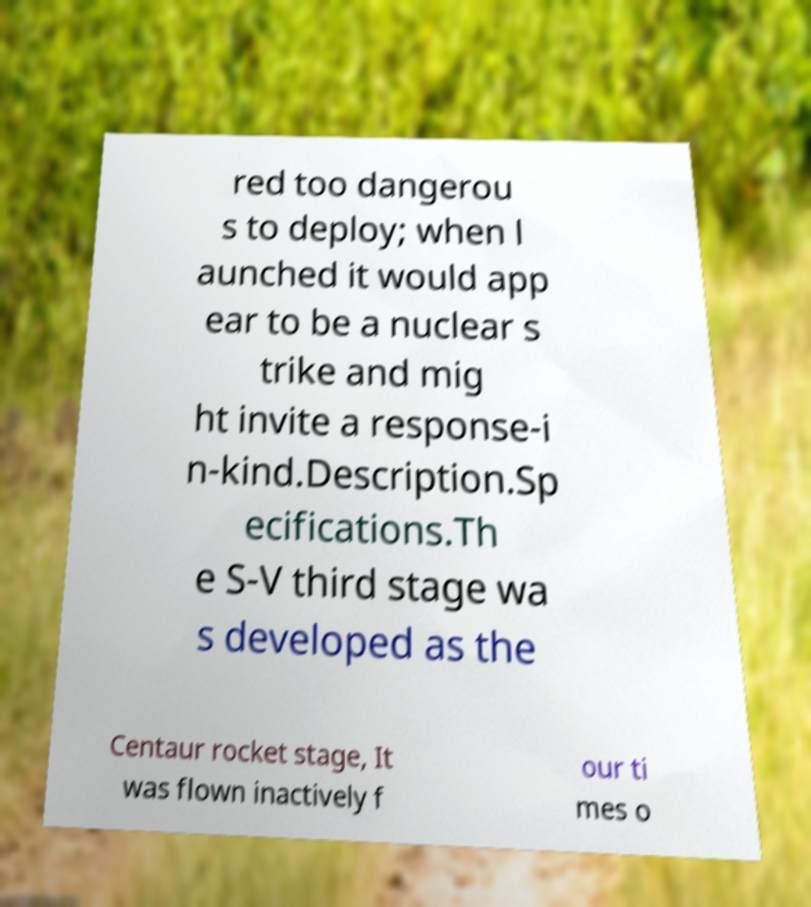Can you read and provide the text displayed in the image?This photo seems to have some interesting text. Can you extract and type it out for me? red too dangerou s to deploy; when l aunched it would app ear to be a nuclear s trike and mig ht invite a response-i n-kind.Description.Sp ecifications.Th e S-V third stage wa s developed as the Centaur rocket stage, It was flown inactively f our ti mes o 